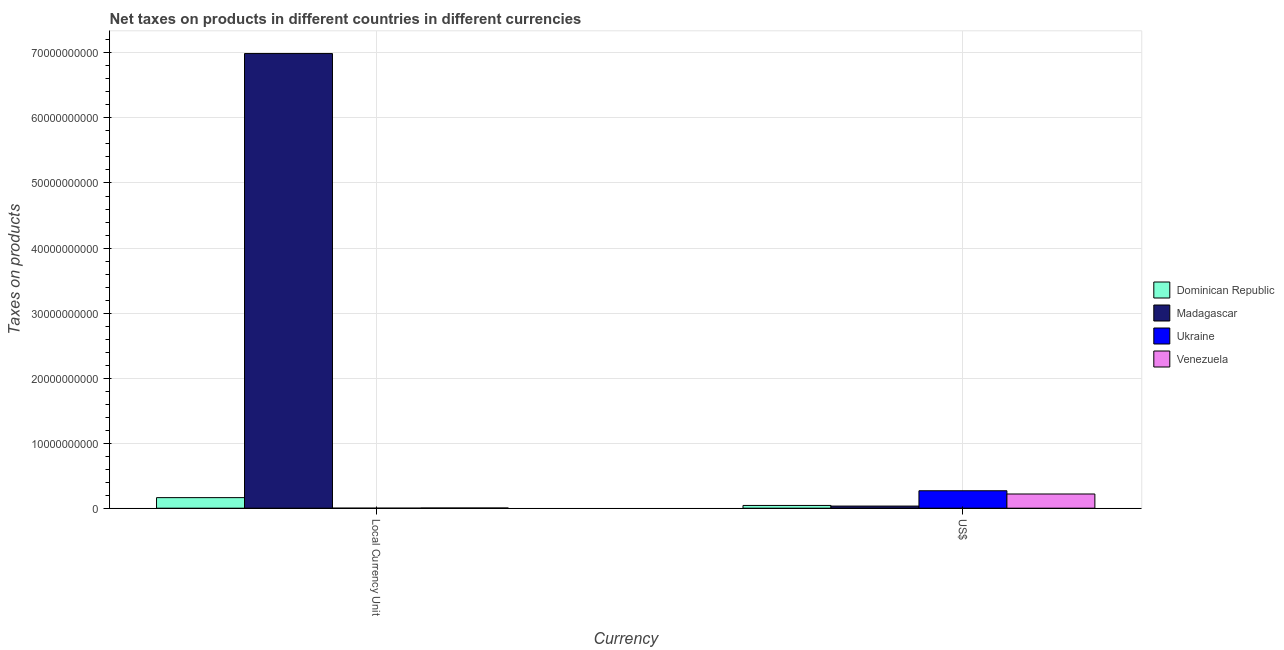Are the number of bars per tick equal to the number of legend labels?
Provide a succinct answer. Yes. Are the number of bars on each tick of the X-axis equal?
Your response must be concise. Yes. How many bars are there on the 2nd tick from the left?
Give a very brief answer. 4. How many bars are there on the 1st tick from the right?
Your answer should be compact. 4. What is the label of the 2nd group of bars from the left?
Your response must be concise. US$. What is the net taxes in constant 2005 us$ in Ukraine?
Give a very brief answer. 5.70e+04. Across all countries, what is the maximum net taxes in constant 2005 us$?
Make the answer very short. 6.99e+1. Across all countries, what is the minimum net taxes in constant 2005 us$?
Ensure brevity in your answer.  5.70e+04. In which country was the net taxes in constant 2005 us$ maximum?
Make the answer very short. Madagascar. In which country was the net taxes in constant 2005 us$ minimum?
Ensure brevity in your answer.  Ukraine. What is the total net taxes in us$ in the graph?
Provide a short and direct response. 5.61e+09. What is the difference between the net taxes in constant 2005 us$ in Venezuela and that in Madagascar?
Offer a terse response. -6.99e+1. What is the difference between the net taxes in constant 2005 us$ in Ukraine and the net taxes in us$ in Madagascar?
Offer a terse response. -3.27e+08. What is the average net taxes in constant 2005 us$ per country?
Offer a terse response. 1.79e+1. What is the difference between the net taxes in us$ and net taxes in constant 2005 us$ in Dominican Republic?
Your response must be concise. -1.20e+09. What is the ratio of the net taxes in us$ in Venezuela to that in Madagascar?
Provide a succinct answer. 6.68. Is the net taxes in us$ in Dominican Republic less than that in Ukraine?
Your answer should be compact. Yes. In how many countries, is the net taxes in us$ greater than the average net taxes in us$ taken over all countries?
Your answer should be compact. 2. What does the 3rd bar from the left in Local Currency Unit represents?
Keep it short and to the point. Ukraine. What does the 4th bar from the right in US$ represents?
Your answer should be very brief. Dominican Republic. How many bars are there?
Provide a succinct answer. 8. What is the difference between two consecutive major ticks on the Y-axis?
Offer a very short reply. 1.00e+1. Where does the legend appear in the graph?
Make the answer very short. Center right. How are the legend labels stacked?
Your answer should be very brief. Vertical. What is the title of the graph?
Your answer should be very brief. Net taxes on products in different countries in different currencies. Does "Sub-Saharan Africa (all income levels)" appear as one of the legend labels in the graph?
Your answer should be very brief. No. What is the label or title of the X-axis?
Provide a succinct answer. Currency. What is the label or title of the Y-axis?
Offer a very short reply. Taxes on products. What is the Taxes on products in Dominican Republic in Local Currency Unit?
Offer a terse response. 1.62e+09. What is the Taxes on products of Madagascar in Local Currency Unit?
Provide a succinct answer. 6.99e+1. What is the Taxes on products in Ukraine in Local Currency Unit?
Provide a succinct answer. 5.70e+04. What is the Taxes on products in Venezuela in Local Currency Unit?
Offer a terse response. 3.16e+07. What is the Taxes on products in Dominican Republic in US$?
Your response must be concise. 4.22e+08. What is the Taxes on products of Madagascar in US$?
Provide a succinct answer. 3.27e+08. What is the Taxes on products in Ukraine in US$?
Ensure brevity in your answer.  2.68e+09. What is the Taxes on products in Venezuela in US$?
Make the answer very short. 2.18e+09. Across all Currency, what is the maximum Taxes on products of Dominican Republic?
Provide a short and direct response. 1.62e+09. Across all Currency, what is the maximum Taxes on products in Madagascar?
Your answer should be compact. 6.99e+1. Across all Currency, what is the maximum Taxes on products in Ukraine?
Keep it short and to the point. 2.68e+09. Across all Currency, what is the maximum Taxes on products of Venezuela?
Give a very brief answer. 2.18e+09. Across all Currency, what is the minimum Taxes on products in Dominican Republic?
Your answer should be compact. 4.22e+08. Across all Currency, what is the minimum Taxes on products in Madagascar?
Provide a succinct answer. 3.27e+08. Across all Currency, what is the minimum Taxes on products in Ukraine?
Offer a very short reply. 5.70e+04. Across all Currency, what is the minimum Taxes on products of Venezuela?
Offer a very short reply. 3.16e+07. What is the total Taxes on products of Dominican Republic in the graph?
Give a very brief answer. 2.05e+09. What is the total Taxes on products of Madagascar in the graph?
Ensure brevity in your answer.  7.02e+1. What is the total Taxes on products in Ukraine in the graph?
Give a very brief answer. 2.68e+09. What is the total Taxes on products in Venezuela in the graph?
Offer a very short reply. 2.21e+09. What is the difference between the Taxes on products in Dominican Republic in Local Currency Unit and that in US$?
Ensure brevity in your answer.  1.20e+09. What is the difference between the Taxes on products in Madagascar in Local Currency Unit and that in US$?
Make the answer very short. 6.96e+1. What is the difference between the Taxes on products of Ukraine in Local Currency Unit and that in US$?
Your answer should be compact. -2.68e+09. What is the difference between the Taxes on products in Venezuela in Local Currency Unit and that in US$?
Your response must be concise. -2.15e+09. What is the difference between the Taxes on products in Dominican Republic in Local Currency Unit and the Taxes on products in Madagascar in US$?
Provide a succinct answer. 1.30e+09. What is the difference between the Taxes on products in Dominican Republic in Local Currency Unit and the Taxes on products in Ukraine in US$?
Your response must be concise. -1.06e+09. What is the difference between the Taxes on products in Dominican Republic in Local Currency Unit and the Taxes on products in Venezuela in US$?
Provide a succinct answer. -5.59e+08. What is the difference between the Taxes on products in Madagascar in Local Currency Unit and the Taxes on products in Ukraine in US$?
Your answer should be compact. 6.72e+1. What is the difference between the Taxes on products of Madagascar in Local Currency Unit and the Taxes on products of Venezuela in US$?
Keep it short and to the point. 6.77e+1. What is the difference between the Taxes on products of Ukraine in Local Currency Unit and the Taxes on products of Venezuela in US$?
Provide a succinct answer. -2.18e+09. What is the average Taxes on products in Dominican Republic per Currency?
Keep it short and to the point. 1.02e+09. What is the average Taxes on products of Madagascar per Currency?
Your answer should be very brief. 3.51e+1. What is the average Taxes on products in Ukraine per Currency?
Offer a very short reply. 1.34e+09. What is the average Taxes on products in Venezuela per Currency?
Give a very brief answer. 1.11e+09. What is the difference between the Taxes on products of Dominican Republic and Taxes on products of Madagascar in Local Currency Unit?
Keep it short and to the point. -6.83e+1. What is the difference between the Taxes on products of Dominican Republic and Taxes on products of Ukraine in Local Currency Unit?
Ensure brevity in your answer.  1.62e+09. What is the difference between the Taxes on products in Dominican Republic and Taxes on products in Venezuela in Local Currency Unit?
Provide a short and direct response. 1.59e+09. What is the difference between the Taxes on products of Madagascar and Taxes on products of Ukraine in Local Currency Unit?
Your response must be concise. 6.99e+1. What is the difference between the Taxes on products of Madagascar and Taxes on products of Venezuela in Local Currency Unit?
Provide a short and direct response. 6.99e+1. What is the difference between the Taxes on products of Ukraine and Taxes on products of Venezuela in Local Currency Unit?
Provide a succinct answer. -3.16e+07. What is the difference between the Taxes on products in Dominican Republic and Taxes on products in Madagascar in US$?
Your answer should be compact. 9.54e+07. What is the difference between the Taxes on products of Dominican Republic and Taxes on products of Ukraine in US$?
Provide a short and direct response. -2.26e+09. What is the difference between the Taxes on products in Dominican Republic and Taxes on products in Venezuela in US$?
Your answer should be very brief. -1.76e+09. What is the difference between the Taxes on products of Madagascar and Taxes on products of Ukraine in US$?
Offer a very short reply. -2.35e+09. What is the difference between the Taxes on products of Madagascar and Taxes on products of Venezuela in US$?
Offer a terse response. -1.86e+09. What is the difference between the Taxes on products of Ukraine and Taxes on products of Venezuela in US$?
Provide a short and direct response. 4.98e+08. What is the ratio of the Taxes on products of Dominican Republic in Local Currency Unit to that in US$?
Ensure brevity in your answer.  3.84. What is the ratio of the Taxes on products in Madagascar in Local Currency Unit to that in US$?
Make the answer very short. 213.84. What is the ratio of the Taxes on products of Ukraine in Local Currency Unit to that in US$?
Provide a short and direct response. 0. What is the ratio of the Taxes on products of Venezuela in Local Currency Unit to that in US$?
Make the answer very short. 0.01. What is the difference between the highest and the second highest Taxes on products of Dominican Republic?
Give a very brief answer. 1.20e+09. What is the difference between the highest and the second highest Taxes on products of Madagascar?
Ensure brevity in your answer.  6.96e+1. What is the difference between the highest and the second highest Taxes on products in Ukraine?
Your answer should be very brief. 2.68e+09. What is the difference between the highest and the second highest Taxes on products of Venezuela?
Your response must be concise. 2.15e+09. What is the difference between the highest and the lowest Taxes on products in Dominican Republic?
Offer a terse response. 1.20e+09. What is the difference between the highest and the lowest Taxes on products in Madagascar?
Your response must be concise. 6.96e+1. What is the difference between the highest and the lowest Taxes on products of Ukraine?
Offer a terse response. 2.68e+09. What is the difference between the highest and the lowest Taxes on products in Venezuela?
Keep it short and to the point. 2.15e+09. 